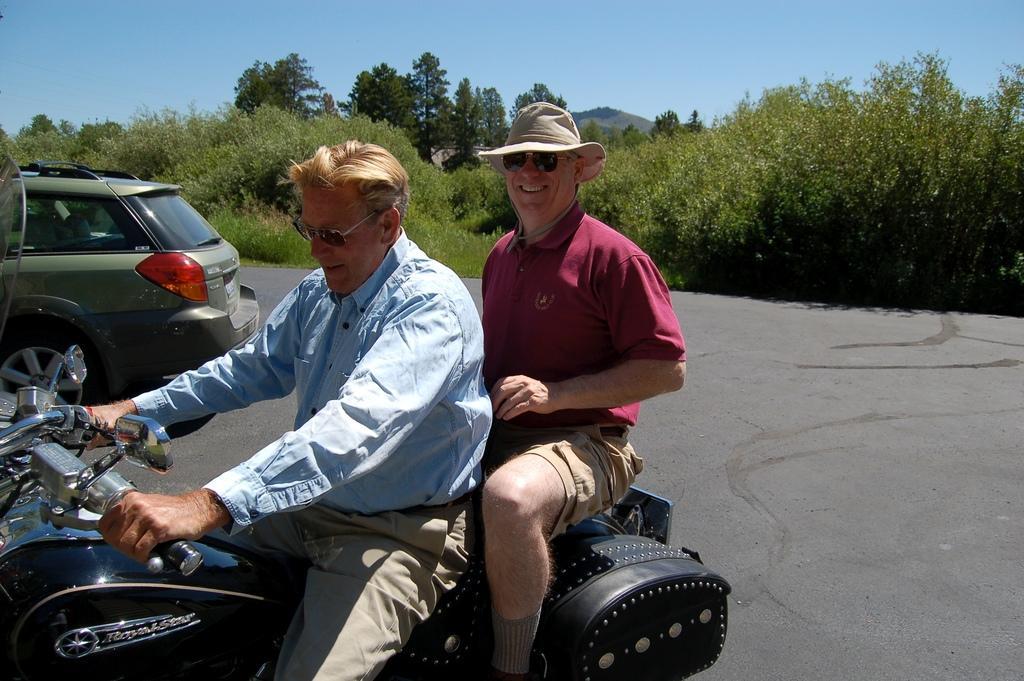How would you summarize this image in a sentence or two? this picture shows a man riding on the motorcycle and a person sitting on the back and we see a car parked and few trees on their back. 